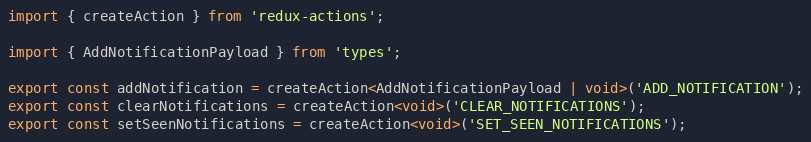<code> <loc_0><loc_0><loc_500><loc_500><_TypeScript_>import { createAction } from 'redux-actions';

import { AddNotificationPayload } from 'types';

export const addNotification = createAction<AddNotificationPayload | void>('ADD_NOTIFICATION');
export const clearNotifications = createAction<void>('CLEAR_NOTIFICATIONS');
export const setSeenNotifications = createAction<void>('SET_SEEN_NOTIFICATIONS');
</code> 